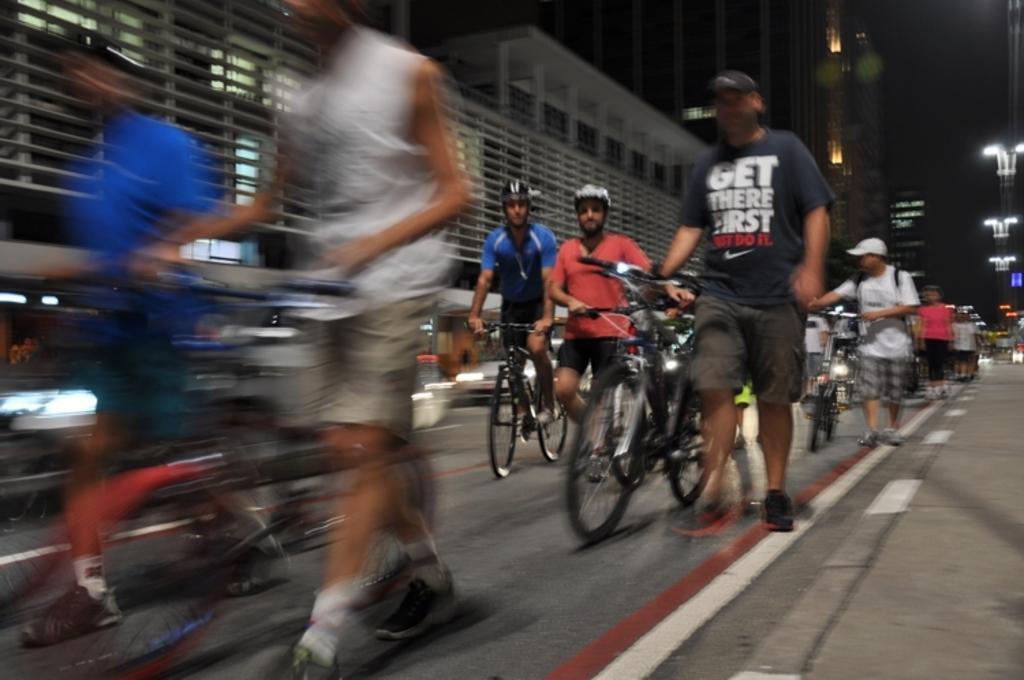Can you describe this image briefly? In this picture there are group of people, they are riding the bicycle, it seems to be a view of road and there are buildings at the right side of the image. 